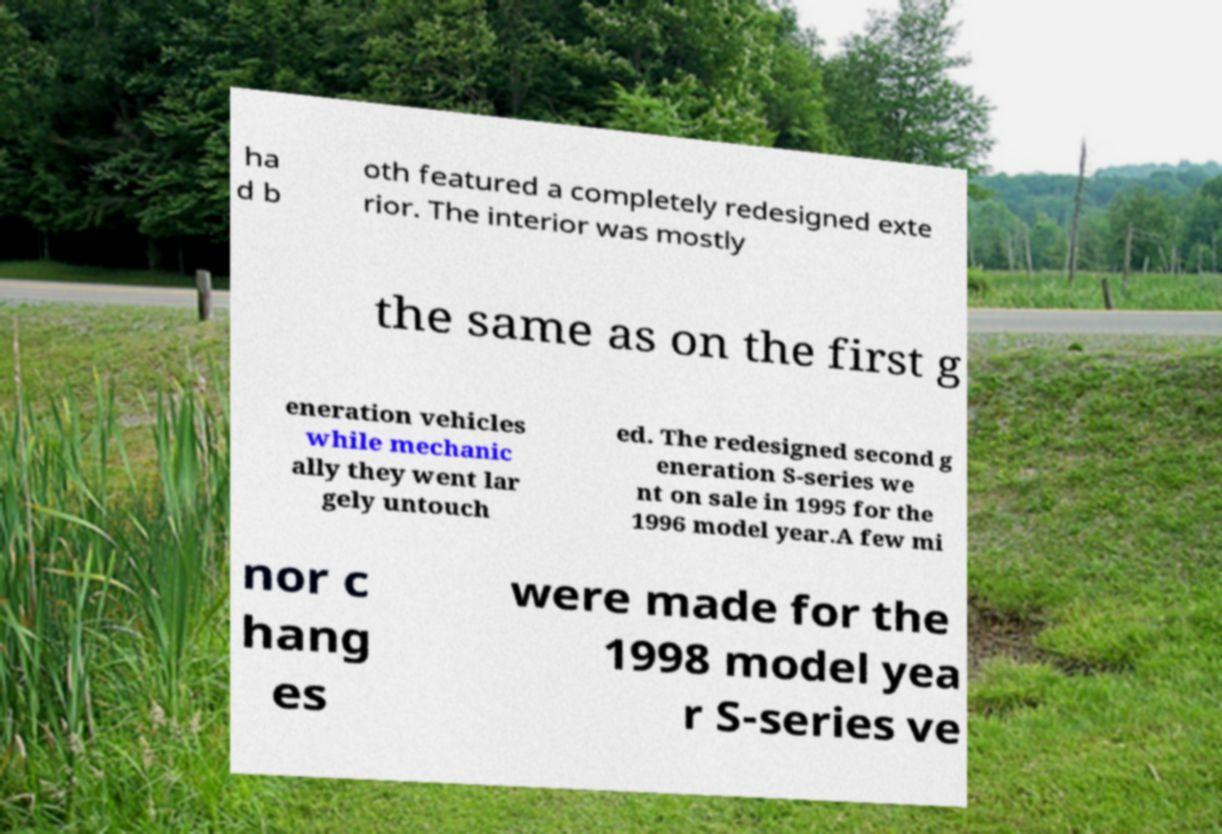Can you read and provide the text displayed in the image?This photo seems to have some interesting text. Can you extract and type it out for me? ha d b oth featured a completely redesigned exte rior. The interior was mostly the same as on the first g eneration vehicles while mechanic ally they went lar gely untouch ed. The redesigned second g eneration S-series we nt on sale in 1995 for the 1996 model year.A few mi nor c hang es were made for the 1998 model yea r S-series ve 